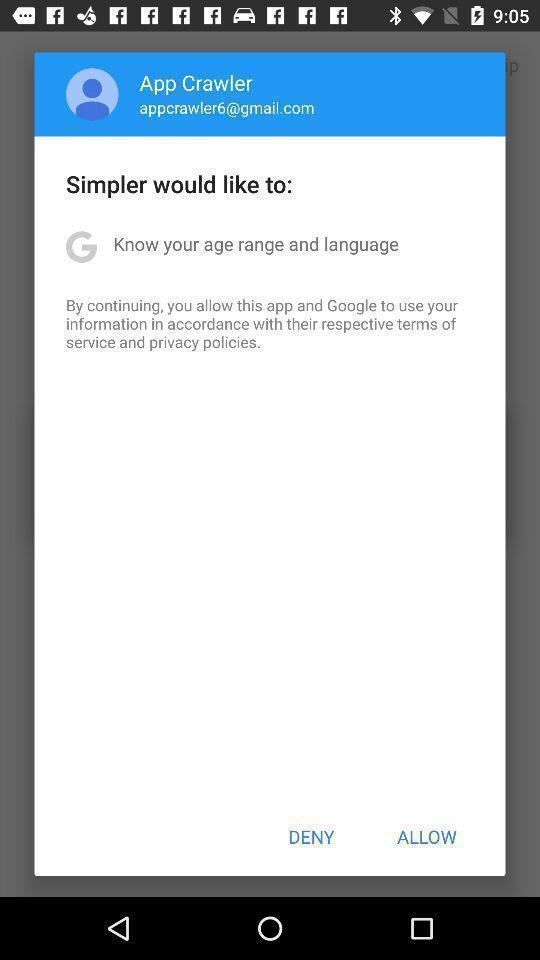Summarize the information in this screenshot. Pop up shows to deny or allow the app. 